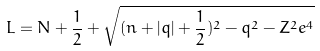<formula> <loc_0><loc_0><loc_500><loc_500>L = N + \frac { 1 } { 2 } + \sqrt { ( n + | q | + \frac { 1 } { 2 } ) ^ { 2 } - q ^ { 2 } - Z ^ { 2 } e ^ { 4 } }</formula> 